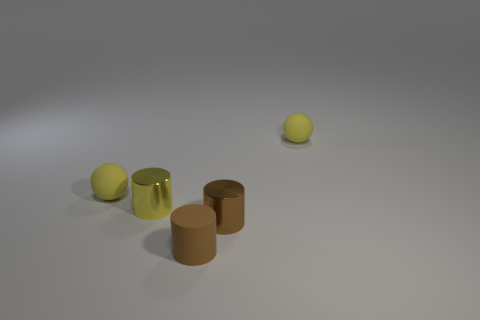Subtract all small metal cylinders. How many cylinders are left? 1 Subtract all brown balls. How many brown cylinders are left? 2 Subtract all purple cylinders. Subtract all yellow balls. How many cylinders are left? 3 Add 3 gray balls. How many objects exist? 8 Subtract all cylinders. How many objects are left? 2 Add 3 cylinders. How many cylinders are left? 6 Add 4 small yellow rubber balls. How many small yellow rubber balls exist? 6 Subtract 1 yellow balls. How many objects are left? 4 Subtract all tiny spheres. Subtract all brown rubber cylinders. How many objects are left? 2 